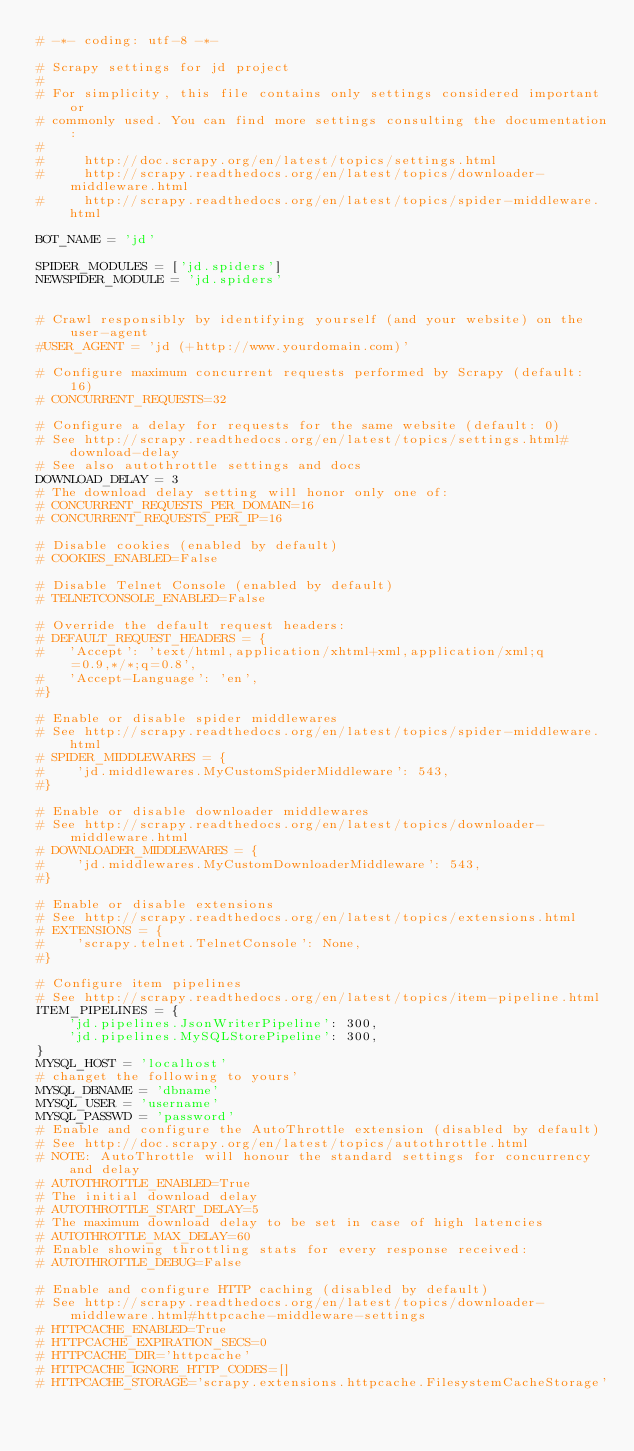<code> <loc_0><loc_0><loc_500><loc_500><_Python_># -*- coding: utf-8 -*-

# Scrapy settings for jd project
#
# For simplicity, this file contains only settings considered important or
# commonly used. You can find more settings consulting the documentation:
#
#     http://doc.scrapy.org/en/latest/topics/settings.html
#     http://scrapy.readthedocs.org/en/latest/topics/downloader-middleware.html
#     http://scrapy.readthedocs.org/en/latest/topics/spider-middleware.html

BOT_NAME = 'jd'

SPIDER_MODULES = ['jd.spiders']
NEWSPIDER_MODULE = 'jd.spiders'


# Crawl responsibly by identifying yourself (and your website) on the user-agent
#USER_AGENT = 'jd (+http://www.yourdomain.com)'

# Configure maximum concurrent requests performed by Scrapy (default: 16)
# CONCURRENT_REQUESTS=32

# Configure a delay for requests for the same website (default: 0)
# See http://scrapy.readthedocs.org/en/latest/topics/settings.html#download-delay
# See also autothrottle settings and docs
DOWNLOAD_DELAY = 3
# The download delay setting will honor only one of:
# CONCURRENT_REQUESTS_PER_DOMAIN=16
# CONCURRENT_REQUESTS_PER_IP=16

# Disable cookies (enabled by default)
# COOKIES_ENABLED=False

# Disable Telnet Console (enabled by default)
# TELNETCONSOLE_ENABLED=False

# Override the default request headers:
# DEFAULT_REQUEST_HEADERS = {
#   'Accept': 'text/html,application/xhtml+xml,application/xml;q=0.9,*/*;q=0.8',
#   'Accept-Language': 'en',
#}

# Enable or disable spider middlewares
# See http://scrapy.readthedocs.org/en/latest/topics/spider-middleware.html
# SPIDER_MIDDLEWARES = {
#    'jd.middlewares.MyCustomSpiderMiddleware': 543,
#}

# Enable or disable downloader middlewares
# See http://scrapy.readthedocs.org/en/latest/topics/downloader-middleware.html
# DOWNLOADER_MIDDLEWARES = {
#    'jd.middlewares.MyCustomDownloaderMiddleware': 543,
#}

# Enable or disable extensions
# See http://scrapy.readthedocs.org/en/latest/topics/extensions.html
# EXTENSIONS = {
#    'scrapy.telnet.TelnetConsole': None,
#}

# Configure item pipelines
# See http://scrapy.readthedocs.org/en/latest/topics/item-pipeline.html
ITEM_PIPELINES = {
    'jd.pipelines.JsonWriterPipeline': 300,
    'jd.pipelines.MySQLStorePipeline': 300,
}
MYSQL_HOST = 'localhost'
# changet the following to yours'
MYSQL_DBNAME = 'dbname'
MYSQL_USER = 'username'
MYSQL_PASSWD = 'password'
# Enable and configure the AutoThrottle extension (disabled by default)
# See http://doc.scrapy.org/en/latest/topics/autothrottle.html
# NOTE: AutoThrottle will honour the standard settings for concurrency and delay
# AUTOTHROTTLE_ENABLED=True
# The initial download delay
# AUTOTHROTTLE_START_DELAY=5
# The maximum download delay to be set in case of high latencies
# AUTOTHROTTLE_MAX_DELAY=60
# Enable showing throttling stats for every response received:
# AUTOTHROTTLE_DEBUG=False

# Enable and configure HTTP caching (disabled by default)
# See http://scrapy.readthedocs.org/en/latest/topics/downloader-middleware.html#httpcache-middleware-settings
# HTTPCACHE_ENABLED=True
# HTTPCACHE_EXPIRATION_SECS=0
# HTTPCACHE_DIR='httpcache'
# HTTPCACHE_IGNORE_HTTP_CODES=[]
# HTTPCACHE_STORAGE='scrapy.extensions.httpcache.FilesystemCacheStorage'
</code> 